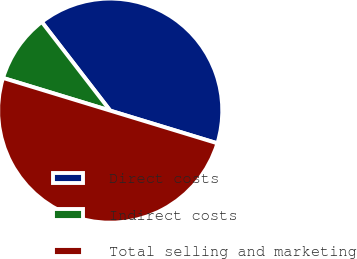<chart> <loc_0><loc_0><loc_500><loc_500><pie_chart><fcel>Direct costs<fcel>Indirect costs<fcel>Total selling and marketing<nl><fcel>40.17%<fcel>9.83%<fcel>50.0%<nl></chart> 